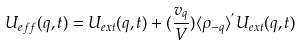Convert formula to latex. <formula><loc_0><loc_0><loc_500><loc_500>U _ { e f f } ( { q } , t ) = U _ { e x t } ( { q } , t ) + ( \frac { v _ { q } } { V } ) \langle \rho _ { - { q } } \rangle ^ { ^ { \prime } } U _ { e x t } ( { q } , t )</formula> 